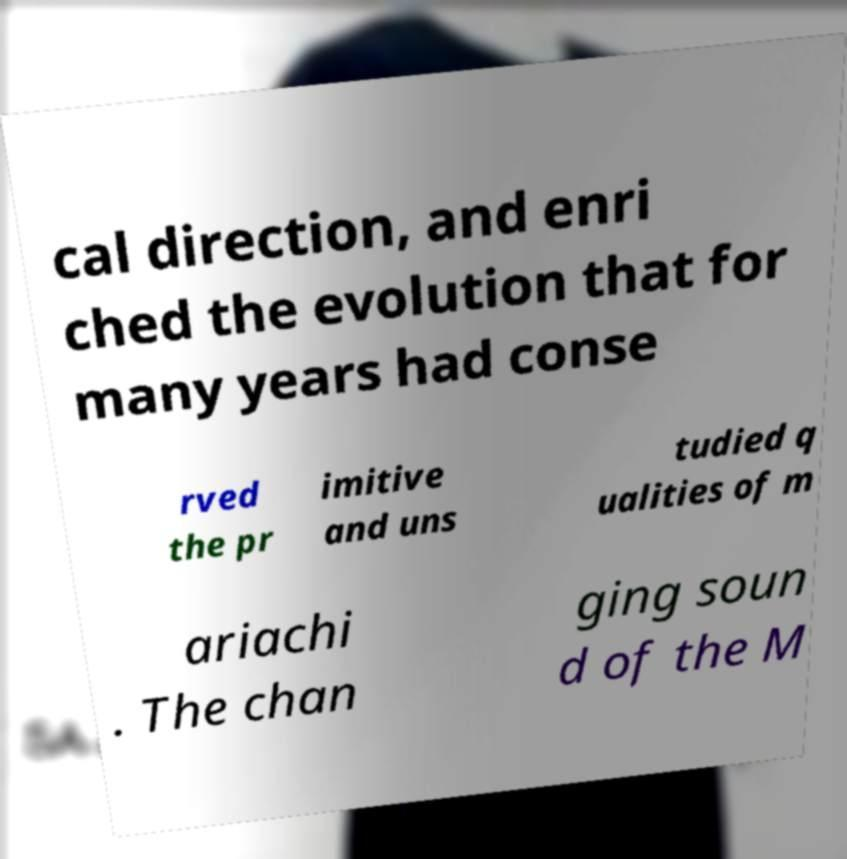What messages or text are displayed in this image? I need them in a readable, typed format. cal direction, and enri ched the evolution that for many years had conse rved the pr imitive and uns tudied q ualities of m ariachi . The chan ging soun d of the M 